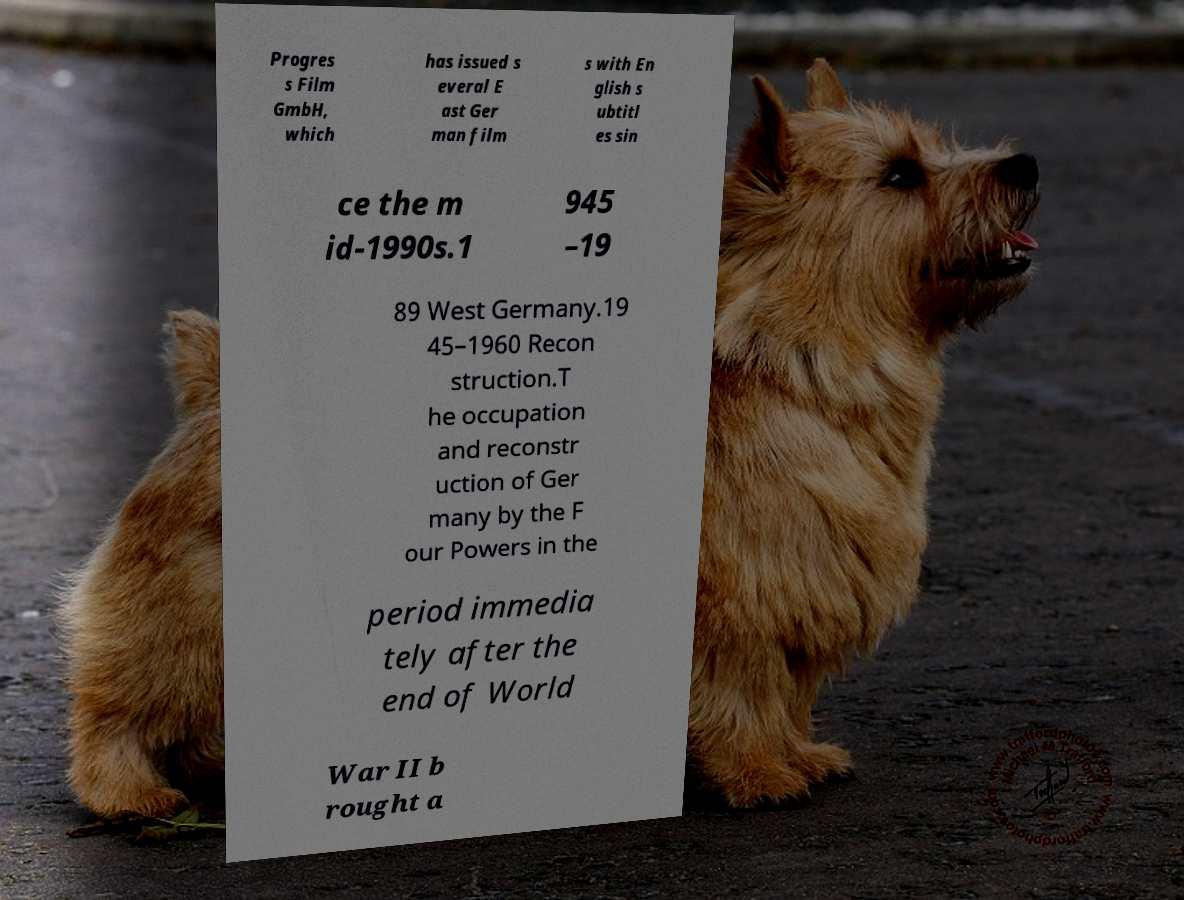Can you accurately transcribe the text from the provided image for me? Progres s Film GmbH, which has issued s everal E ast Ger man film s with En glish s ubtitl es sin ce the m id-1990s.1 945 –19 89 West Germany.19 45–1960 Recon struction.T he occupation and reconstr uction of Ger many by the F our Powers in the period immedia tely after the end of World War II b rought a 